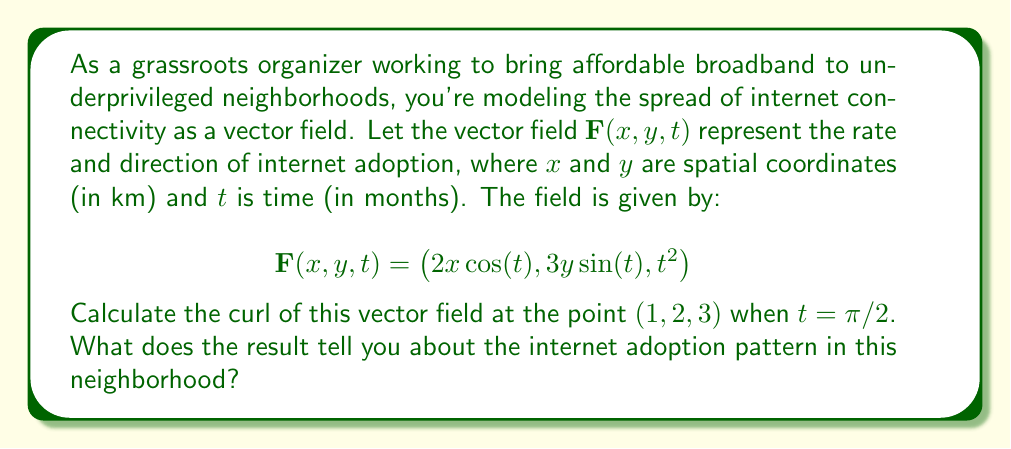Help me with this question. To solve this problem, we need to follow these steps:

1) The curl of a vector field $\mathbf{F}(x, y, z) = (P, Q, R)$ in 3D is defined as:

   $$\text{curl } \mathbf{F} = \nabla \times \mathbf{F} = \left(\frac{\partial R}{\partial y} - \frac{\partial Q}{\partial z}\right)\mathbf{i} + \left(\frac{\partial P}{\partial z} - \frac{\partial R}{\partial x}\right)\mathbf{j} + \left(\frac{\partial Q}{\partial x} - \frac{\partial P}{\partial y}\right)\mathbf{k}$$

2) In our case, $P = 2x\cos(t)$, $Q = 3y\sin(t)$, and $R = t^2$. We need to calculate the partial derivatives:

   $\frac{\partial R}{\partial y} = 0$
   $\frac{\partial Q}{\partial z} = 0$ (as there's no z-dependence)
   $\frac{\partial P}{\partial z} = 0$ (as there's no z-dependence)
   $\frac{\partial R}{\partial x} = 0$
   $\frac{\partial Q}{\partial x} = 0$
   $\frac{\partial P}{\partial y} = 0$

3) Substituting these into the curl formula:

   $$\text{curl } \mathbf{F} = (0 - 0)\mathbf{i} + (0 - 0)\mathbf{j} + (0 - 0)\mathbf{k} = \mathbf{0}$$

4) This result is independent of $x$, $y$, and $t$, so it holds for the point $(1, 2, 3)$ when $t = \pi/2$.

The zero curl indicates that the vector field is irrotational, meaning there are no localized circular flows or vortices in the internet adoption pattern. In the context of internet adoption, this suggests that the spread of connectivity is uniform and doesn't have areas of concentrated growth or stagnation relative to their surroundings.
Answer: The curl of the vector field at $(1, 2, 3)$ when $t = \pi/2$ is $\mathbf{0}$, indicating an irrotational field with uniform spread of internet connectivity without localized areas of concentrated growth or stagnation. 